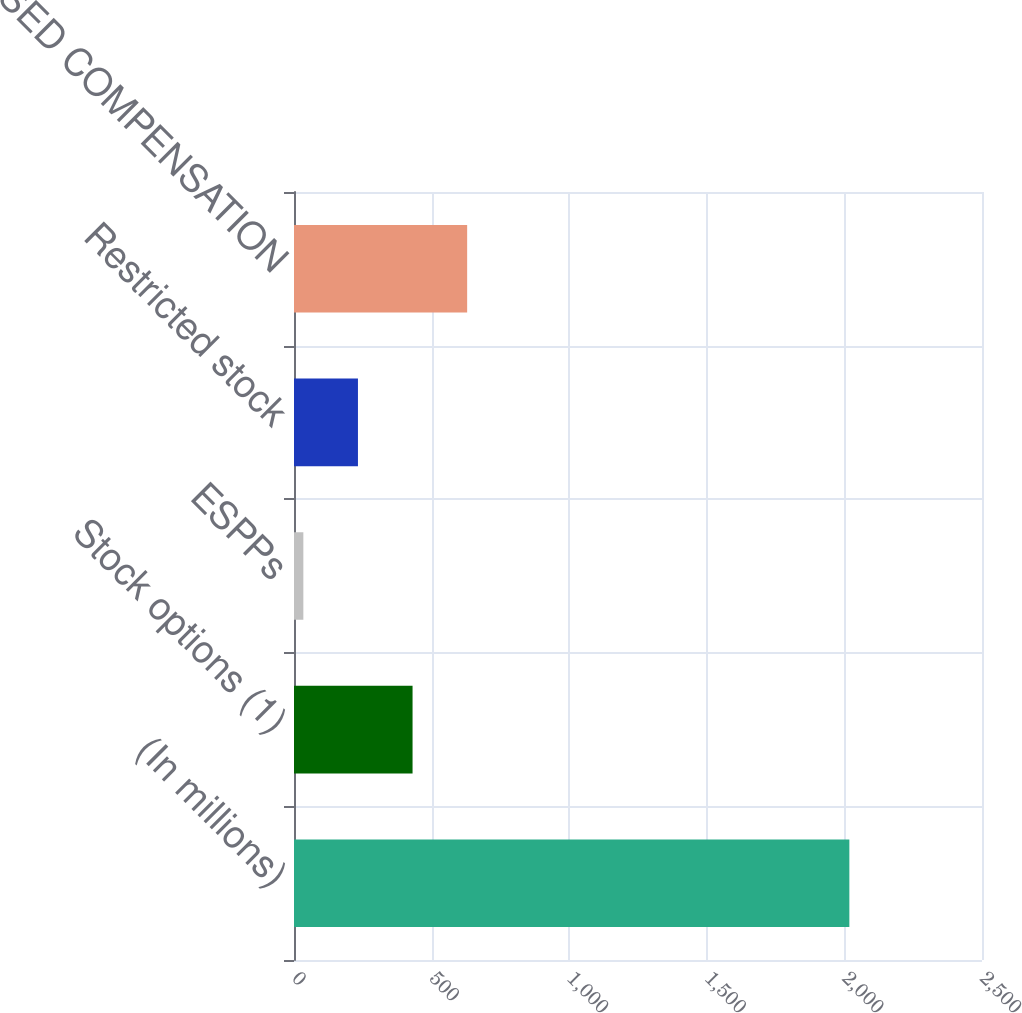<chart> <loc_0><loc_0><loc_500><loc_500><bar_chart><fcel>(In millions)<fcel>Stock options (1)<fcel>ESPPs<fcel>Restricted stock<fcel>TOTAL STOCK-BASED COMPENSATION<nl><fcel>2018<fcel>430.8<fcel>34<fcel>232.4<fcel>629.2<nl></chart> 